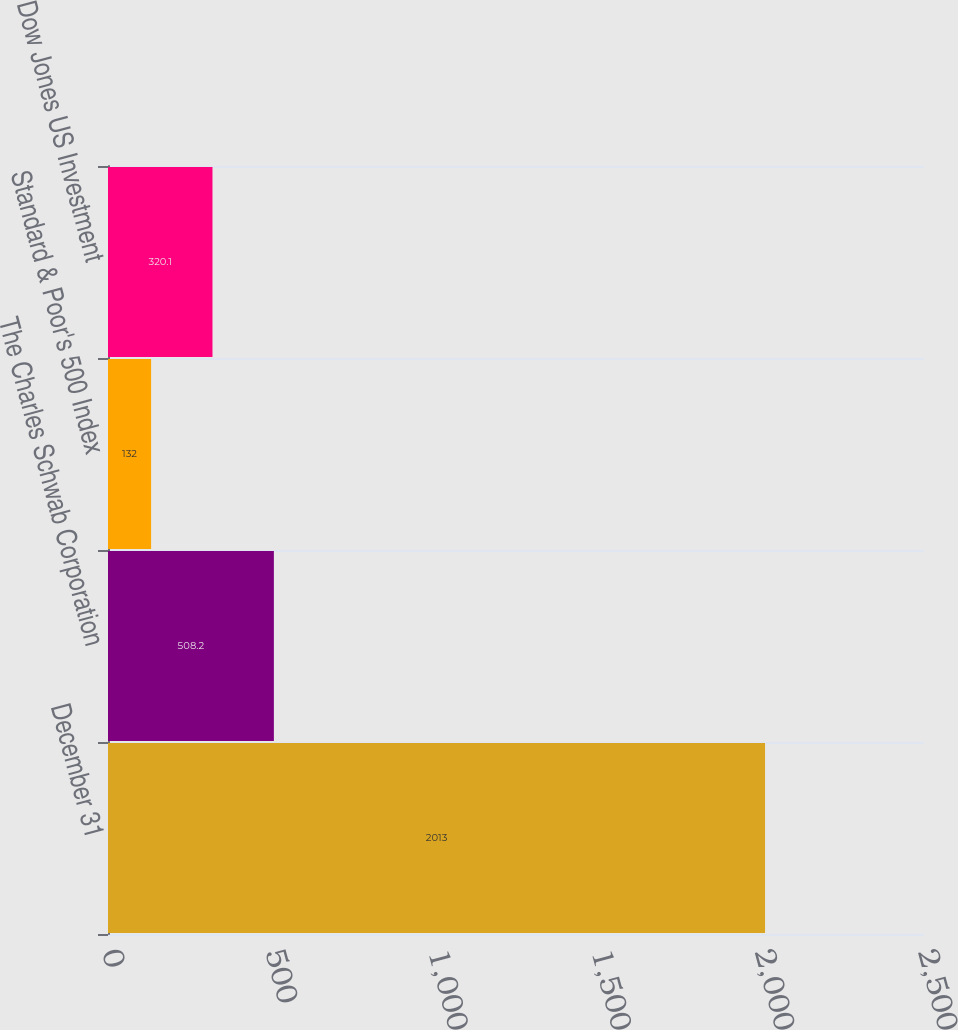Convert chart to OTSL. <chart><loc_0><loc_0><loc_500><loc_500><bar_chart><fcel>December 31<fcel>The Charles Schwab Corporation<fcel>Standard & Poor's 500 Index<fcel>Dow Jones US Investment<nl><fcel>2013<fcel>508.2<fcel>132<fcel>320.1<nl></chart> 